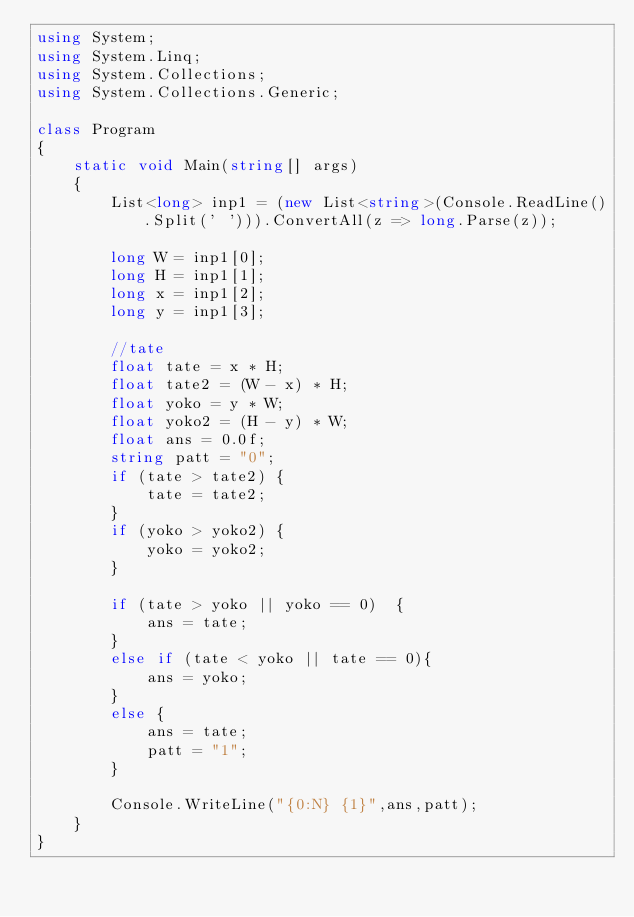<code> <loc_0><loc_0><loc_500><loc_500><_C#_>using System;
using System.Linq;
using System.Collections;
using System.Collections.Generic;

class Program
{
    static void Main(string[] args)
    {
        List<long> inp1 = (new List<string>(Console.ReadLine().Split(' '))).ConvertAll(z => long.Parse(z));
        
        long W = inp1[0];
        long H = inp1[1];
        long x = inp1[2];
        long y = inp1[3];
        
        //tate
        float tate = x * H;
        float tate2 = (W - x) * H;
        float yoko = y * W;
        float yoko2 = (H - y) * W;
        float ans = 0.0f;
        string patt = "0";
        if (tate > tate2) {
            tate = tate2;
        }
        if (yoko > yoko2) {
            yoko = yoko2;
        }
        
        if (tate > yoko || yoko == 0)  {
            ans = tate;
        }
        else if (tate < yoko || tate == 0){
            ans = yoko;
        }
        else {
            ans = tate;
            patt = "1";
        }

        Console.WriteLine("{0:N} {1}",ans,patt);
    }
}
</code> 